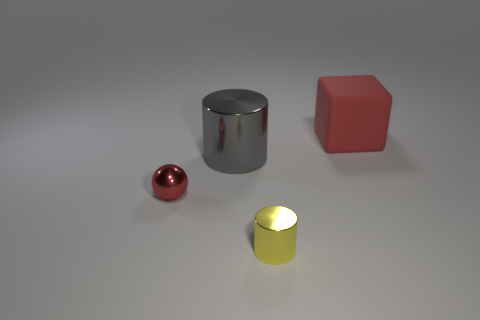Is there any other thing that is made of the same material as the large red object?
Provide a succinct answer. No. The other object that is the same color as the rubber thing is what shape?
Make the answer very short. Sphere. Does the small thing left of the tiny yellow object have the same color as the cube?
Ensure brevity in your answer.  Yes. Is the size of the cylinder that is behind the red metal ball the same as the big matte thing?
Your response must be concise. Yes. What shape is the big red object?
Offer a terse response. Cube. How many red objects have the same shape as the tiny yellow thing?
Keep it short and to the point. 0. How many red objects are in front of the large matte cube and behind the big cylinder?
Make the answer very short. 0. The big metallic object has what color?
Offer a very short reply. Gray. Is there a small object that has the same material as the large gray cylinder?
Your answer should be compact. Yes. Is there a metal sphere right of the red object in front of the big object right of the large gray metal cylinder?
Ensure brevity in your answer.  No. 